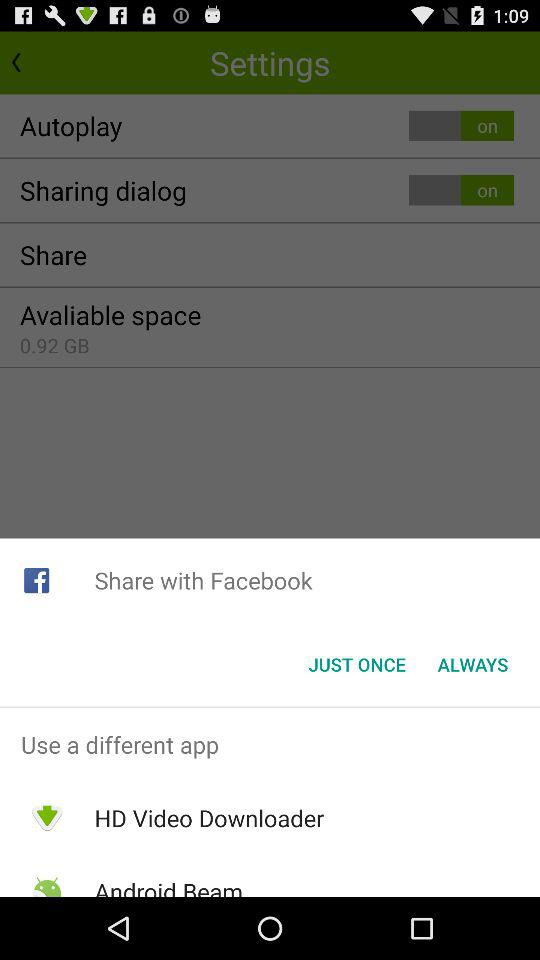What applications can be used to share? The applications that can be used to share are "Facebook", "HD Video Downloader" and "Android Beam". 